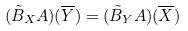<formula> <loc_0><loc_0><loc_500><loc_500>( \tilde { B } _ { X } { A } ) ( \overline { Y } ) = ( \tilde { B } _ { Y } { A } ) ( \overline { X } )</formula> 